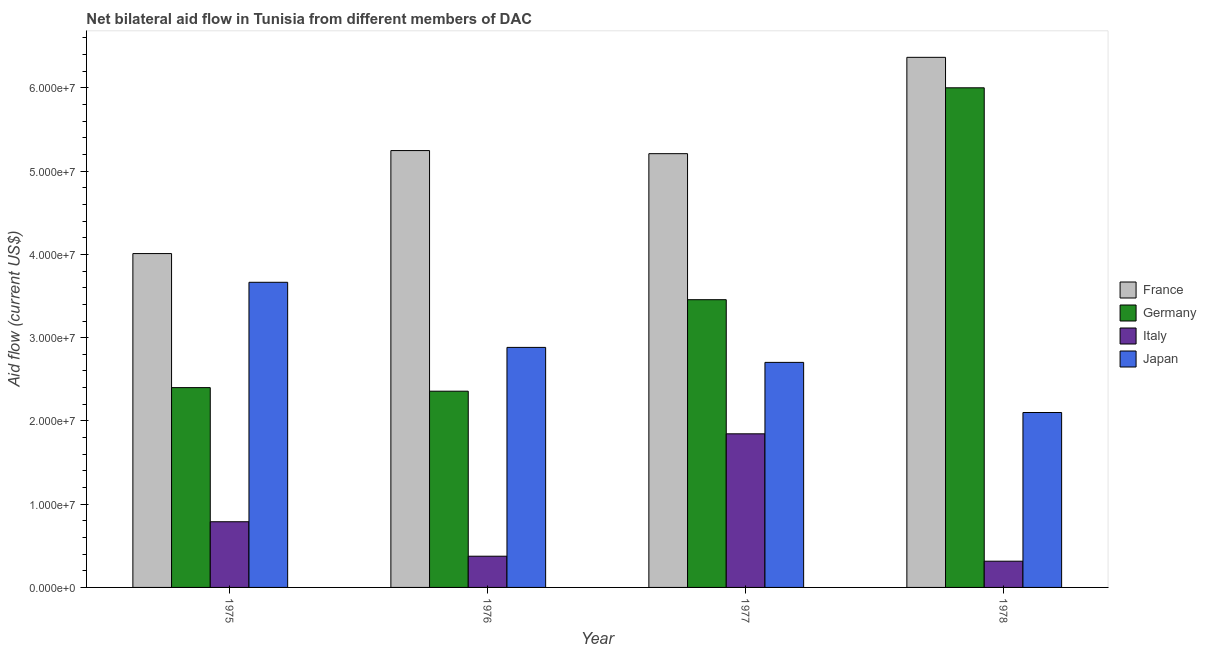Are the number of bars per tick equal to the number of legend labels?
Ensure brevity in your answer.  Yes. What is the label of the 4th group of bars from the left?
Offer a terse response. 1978. In how many cases, is the number of bars for a given year not equal to the number of legend labels?
Offer a very short reply. 0. What is the amount of aid given by japan in 1977?
Provide a short and direct response. 2.70e+07. Across all years, what is the maximum amount of aid given by france?
Your answer should be very brief. 6.37e+07. Across all years, what is the minimum amount of aid given by germany?
Give a very brief answer. 2.36e+07. In which year was the amount of aid given by italy maximum?
Ensure brevity in your answer.  1977. In which year was the amount of aid given by japan minimum?
Offer a very short reply. 1978. What is the total amount of aid given by italy in the graph?
Provide a short and direct response. 3.32e+07. What is the difference between the amount of aid given by japan in 1975 and that in 1976?
Make the answer very short. 7.82e+06. What is the difference between the amount of aid given by japan in 1976 and the amount of aid given by france in 1977?
Give a very brief answer. 1.80e+06. What is the average amount of aid given by italy per year?
Give a very brief answer. 8.31e+06. In the year 1977, what is the difference between the amount of aid given by italy and amount of aid given by france?
Your response must be concise. 0. What is the ratio of the amount of aid given by japan in 1976 to that in 1978?
Keep it short and to the point. 1.37. Is the amount of aid given by italy in 1976 less than that in 1978?
Make the answer very short. No. What is the difference between the highest and the second highest amount of aid given by germany?
Make the answer very short. 2.54e+07. What is the difference between the highest and the lowest amount of aid given by france?
Give a very brief answer. 2.36e+07. Is the sum of the amount of aid given by italy in 1975 and 1976 greater than the maximum amount of aid given by france across all years?
Offer a very short reply. No. Is it the case that in every year, the sum of the amount of aid given by france and amount of aid given by japan is greater than the sum of amount of aid given by germany and amount of aid given by italy?
Keep it short and to the point. Yes. What does the 1st bar from the left in 1978 represents?
Provide a short and direct response. France. What does the 4th bar from the right in 1976 represents?
Your answer should be very brief. France. Is it the case that in every year, the sum of the amount of aid given by france and amount of aid given by germany is greater than the amount of aid given by italy?
Offer a terse response. Yes. Does the graph contain any zero values?
Provide a succinct answer. No. How many legend labels are there?
Ensure brevity in your answer.  4. How are the legend labels stacked?
Provide a short and direct response. Vertical. What is the title of the graph?
Give a very brief answer. Net bilateral aid flow in Tunisia from different members of DAC. Does "Minerals" appear as one of the legend labels in the graph?
Provide a succinct answer. No. What is the Aid flow (current US$) of France in 1975?
Your answer should be very brief. 4.01e+07. What is the Aid flow (current US$) of Germany in 1975?
Provide a succinct answer. 2.40e+07. What is the Aid flow (current US$) in Italy in 1975?
Give a very brief answer. 7.89e+06. What is the Aid flow (current US$) of Japan in 1975?
Your answer should be very brief. 3.66e+07. What is the Aid flow (current US$) of France in 1976?
Provide a short and direct response. 5.25e+07. What is the Aid flow (current US$) of Germany in 1976?
Keep it short and to the point. 2.36e+07. What is the Aid flow (current US$) of Italy in 1976?
Your answer should be compact. 3.75e+06. What is the Aid flow (current US$) of Japan in 1976?
Offer a terse response. 2.88e+07. What is the Aid flow (current US$) of France in 1977?
Ensure brevity in your answer.  5.21e+07. What is the Aid flow (current US$) in Germany in 1977?
Ensure brevity in your answer.  3.46e+07. What is the Aid flow (current US$) in Italy in 1977?
Make the answer very short. 1.84e+07. What is the Aid flow (current US$) in Japan in 1977?
Offer a terse response. 2.70e+07. What is the Aid flow (current US$) in France in 1978?
Provide a succinct answer. 6.37e+07. What is the Aid flow (current US$) of Germany in 1978?
Offer a terse response. 6.00e+07. What is the Aid flow (current US$) in Italy in 1978?
Ensure brevity in your answer.  3.15e+06. What is the Aid flow (current US$) in Japan in 1978?
Provide a succinct answer. 2.10e+07. Across all years, what is the maximum Aid flow (current US$) in France?
Keep it short and to the point. 6.37e+07. Across all years, what is the maximum Aid flow (current US$) of Germany?
Your answer should be compact. 6.00e+07. Across all years, what is the maximum Aid flow (current US$) of Italy?
Give a very brief answer. 1.84e+07. Across all years, what is the maximum Aid flow (current US$) of Japan?
Give a very brief answer. 3.66e+07. Across all years, what is the minimum Aid flow (current US$) of France?
Ensure brevity in your answer.  4.01e+07. Across all years, what is the minimum Aid flow (current US$) of Germany?
Provide a short and direct response. 2.36e+07. Across all years, what is the minimum Aid flow (current US$) of Italy?
Your answer should be compact. 3.15e+06. Across all years, what is the minimum Aid flow (current US$) of Japan?
Your answer should be compact. 2.10e+07. What is the total Aid flow (current US$) in France in the graph?
Your response must be concise. 2.08e+08. What is the total Aid flow (current US$) in Germany in the graph?
Offer a very short reply. 1.42e+08. What is the total Aid flow (current US$) of Italy in the graph?
Your answer should be compact. 3.32e+07. What is the total Aid flow (current US$) of Japan in the graph?
Your response must be concise. 1.14e+08. What is the difference between the Aid flow (current US$) in France in 1975 and that in 1976?
Your response must be concise. -1.24e+07. What is the difference between the Aid flow (current US$) in Italy in 1975 and that in 1976?
Give a very brief answer. 4.14e+06. What is the difference between the Aid flow (current US$) in Japan in 1975 and that in 1976?
Give a very brief answer. 7.82e+06. What is the difference between the Aid flow (current US$) of France in 1975 and that in 1977?
Keep it short and to the point. -1.20e+07. What is the difference between the Aid flow (current US$) in Germany in 1975 and that in 1977?
Offer a very short reply. -1.06e+07. What is the difference between the Aid flow (current US$) of Italy in 1975 and that in 1977?
Your response must be concise. -1.06e+07. What is the difference between the Aid flow (current US$) in Japan in 1975 and that in 1977?
Your answer should be very brief. 9.62e+06. What is the difference between the Aid flow (current US$) of France in 1975 and that in 1978?
Your answer should be compact. -2.36e+07. What is the difference between the Aid flow (current US$) of Germany in 1975 and that in 1978?
Your response must be concise. -3.60e+07. What is the difference between the Aid flow (current US$) of Italy in 1975 and that in 1978?
Offer a very short reply. 4.74e+06. What is the difference between the Aid flow (current US$) of Japan in 1975 and that in 1978?
Provide a succinct answer. 1.56e+07. What is the difference between the Aid flow (current US$) in Germany in 1976 and that in 1977?
Your answer should be compact. -1.10e+07. What is the difference between the Aid flow (current US$) in Italy in 1976 and that in 1977?
Your answer should be very brief. -1.47e+07. What is the difference between the Aid flow (current US$) in Japan in 1976 and that in 1977?
Offer a terse response. 1.80e+06. What is the difference between the Aid flow (current US$) in France in 1976 and that in 1978?
Provide a succinct answer. -1.12e+07. What is the difference between the Aid flow (current US$) of Germany in 1976 and that in 1978?
Offer a very short reply. -3.64e+07. What is the difference between the Aid flow (current US$) in Italy in 1976 and that in 1978?
Offer a very short reply. 6.00e+05. What is the difference between the Aid flow (current US$) of Japan in 1976 and that in 1978?
Provide a succinct answer. 7.82e+06. What is the difference between the Aid flow (current US$) of France in 1977 and that in 1978?
Make the answer very short. -1.16e+07. What is the difference between the Aid flow (current US$) in Germany in 1977 and that in 1978?
Your answer should be very brief. -2.54e+07. What is the difference between the Aid flow (current US$) in Italy in 1977 and that in 1978?
Your answer should be very brief. 1.53e+07. What is the difference between the Aid flow (current US$) in Japan in 1977 and that in 1978?
Your answer should be very brief. 6.02e+06. What is the difference between the Aid flow (current US$) of France in 1975 and the Aid flow (current US$) of Germany in 1976?
Give a very brief answer. 1.65e+07. What is the difference between the Aid flow (current US$) of France in 1975 and the Aid flow (current US$) of Italy in 1976?
Keep it short and to the point. 3.64e+07. What is the difference between the Aid flow (current US$) of France in 1975 and the Aid flow (current US$) of Japan in 1976?
Give a very brief answer. 1.13e+07. What is the difference between the Aid flow (current US$) in Germany in 1975 and the Aid flow (current US$) in Italy in 1976?
Your answer should be compact. 2.02e+07. What is the difference between the Aid flow (current US$) of Germany in 1975 and the Aid flow (current US$) of Japan in 1976?
Ensure brevity in your answer.  -4.83e+06. What is the difference between the Aid flow (current US$) in Italy in 1975 and the Aid flow (current US$) in Japan in 1976?
Offer a terse response. -2.09e+07. What is the difference between the Aid flow (current US$) of France in 1975 and the Aid flow (current US$) of Germany in 1977?
Offer a terse response. 5.54e+06. What is the difference between the Aid flow (current US$) in France in 1975 and the Aid flow (current US$) in Italy in 1977?
Ensure brevity in your answer.  2.16e+07. What is the difference between the Aid flow (current US$) of France in 1975 and the Aid flow (current US$) of Japan in 1977?
Make the answer very short. 1.31e+07. What is the difference between the Aid flow (current US$) in Germany in 1975 and the Aid flow (current US$) in Italy in 1977?
Your response must be concise. 5.55e+06. What is the difference between the Aid flow (current US$) in Germany in 1975 and the Aid flow (current US$) in Japan in 1977?
Make the answer very short. -3.03e+06. What is the difference between the Aid flow (current US$) of Italy in 1975 and the Aid flow (current US$) of Japan in 1977?
Your answer should be compact. -1.91e+07. What is the difference between the Aid flow (current US$) of France in 1975 and the Aid flow (current US$) of Germany in 1978?
Provide a succinct answer. -1.99e+07. What is the difference between the Aid flow (current US$) in France in 1975 and the Aid flow (current US$) in Italy in 1978?
Your answer should be compact. 3.70e+07. What is the difference between the Aid flow (current US$) of France in 1975 and the Aid flow (current US$) of Japan in 1978?
Keep it short and to the point. 1.91e+07. What is the difference between the Aid flow (current US$) in Germany in 1975 and the Aid flow (current US$) in Italy in 1978?
Your answer should be very brief. 2.08e+07. What is the difference between the Aid flow (current US$) of Germany in 1975 and the Aid flow (current US$) of Japan in 1978?
Offer a terse response. 2.99e+06. What is the difference between the Aid flow (current US$) of Italy in 1975 and the Aid flow (current US$) of Japan in 1978?
Give a very brief answer. -1.31e+07. What is the difference between the Aid flow (current US$) of France in 1976 and the Aid flow (current US$) of Germany in 1977?
Provide a succinct answer. 1.79e+07. What is the difference between the Aid flow (current US$) in France in 1976 and the Aid flow (current US$) in Italy in 1977?
Give a very brief answer. 3.40e+07. What is the difference between the Aid flow (current US$) in France in 1976 and the Aid flow (current US$) in Japan in 1977?
Your response must be concise. 2.54e+07. What is the difference between the Aid flow (current US$) in Germany in 1976 and the Aid flow (current US$) in Italy in 1977?
Your answer should be compact. 5.12e+06. What is the difference between the Aid flow (current US$) of Germany in 1976 and the Aid flow (current US$) of Japan in 1977?
Ensure brevity in your answer.  -3.46e+06. What is the difference between the Aid flow (current US$) in Italy in 1976 and the Aid flow (current US$) in Japan in 1977?
Offer a terse response. -2.33e+07. What is the difference between the Aid flow (current US$) of France in 1976 and the Aid flow (current US$) of Germany in 1978?
Your answer should be very brief. -7.54e+06. What is the difference between the Aid flow (current US$) of France in 1976 and the Aid flow (current US$) of Italy in 1978?
Your answer should be very brief. 4.93e+07. What is the difference between the Aid flow (current US$) in France in 1976 and the Aid flow (current US$) in Japan in 1978?
Provide a succinct answer. 3.15e+07. What is the difference between the Aid flow (current US$) of Germany in 1976 and the Aid flow (current US$) of Italy in 1978?
Keep it short and to the point. 2.04e+07. What is the difference between the Aid flow (current US$) in Germany in 1976 and the Aid flow (current US$) in Japan in 1978?
Your answer should be compact. 2.56e+06. What is the difference between the Aid flow (current US$) in Italy in 1976 and the Aid flow (current US$) in Japan in 1978?
Offer a very short reply. -1.73e+07. What is the difference between the Aid flow (current US$) of France in 1977 and the Aid flow (current US$) of Germany in 1978?
Give a very brief answer. -7.91e+06. What is the difference between the Aid flow (current US$) of France in 1977 and the Aid flow (current US$) of Italy in 1978?
Your response must be concise. 4.90e+07. What is the difference between the Aid flow (current US$) of France in 1977 and the Aid flow (current US$) of Japan in 1978?
Make the answer very short. 3.11e+07. What is the difference between the Aid flow (current US$) in Germany in 1977 and the Aid flow (current US$) in Italy in 1978?
Keep it short and to the point. 3.14e+07. What is the difference between the Aid flow (current US$) in Germany in 1977 and the Aid flow (current US$) in Japan in 1978?
Make the answer very short. 1.36e+07. What is the difference between the Aid flow (current US$) in Italy in 1977 and the Aid flow (current US$) in Japan in 1978?
Provide a short and direct response. -2.56e+06. What is the average Aid flow (current US$) of France per year?
Your answer should be compact. 5.21e+07. What is the average Aid flow (current US$) in Germany per year?
Give a very brief answer. 3.55e+07. What is the average Aid flow (current US$) of Italy per year?
Make the answer very short. 8.31e+06. What is the average Aid flow (current US$) in Japan per year?
Make the answer very short. 2.84e+07. In the year 1975, what is the difference between the Aid flow (current US$) in France and Aid flow (current US$) in Germany?
Provide a short and direct response. 1.61e+07. In the year 1975, what is the difference between the Aid flow (current US$) of France and Aid flow (current US$) of Italy?
Your response must be concise. 3.22e+07. In the year 1975, what is the difference between the Aid flow (current US$) in France and Aid flow (current US$) in Japan?
Keep it short and to the point. 3.45e+06. In the year 1975, what is the difference between the Aid flow (current US$) of Germany and Aid flow (current US$) of Italy?
Your answer should be compact. 1.61e+07. In the year 1975, what is the difference between the Aid flow (current US$) in Germany and Aid flow (current US$) in Japan?
Make the answer very short. -1.26e+07. In the year 1975, what is the difference between the Aid flow (current US$) of Italy and Aid flow (current US$) of Japan?
Your response must be concise. -2.88e+07. In the year 1976, what is the difference between the Aid flow (current US$) in France and Aid flow (current US$) in Germany?
Offer a terse response. 2.89e+07. In the year 1976, what is the difference between the Aid flow (current US$) in France and Aid flow (current US$) in Italy?
Give a very brief answer. 4.87e+07. In the year 1976, what is the difference between the Aid flow (current US$) in France and Aid flow (current US$) in Japan?
Your answer should be compact. 2.36e+07. In the year 1976, what is the difference between the Aid flow (current US$) of Germany and Aid flow (current US$) of Italy?
Your answer should be compact. 1.98e+07. In the year 1976, what is the difference between the Aid flow (current US$) of Germany and Aid flow (current US$) of Japan?
Your answer should be compact. -5.26e+06. In the year 1976, what is the difference between the Aid flow (current US$) of Italy and Aid flow (current US$) of Japan?
Make the answer very short. -2.51e+07. In the year 1977, what is the difference between the Aid flow (current US$) of France and Aid flow (current US$) of Germany?
Your response must be concise. 1.75e+07. In the year 1977, what is the difference between the Aid flow (current US$) of France and Aid flow (current US$) of Italy?
Your answer should be compact. 3.36e+07. In the year 1977, what is the difference between the Aid flow (current US$) of France and Aid flow (current US$) of Japan?
Ensure brevity in your answer.  2.51e+07. In the year 1977, what is the difference between the Aid flow (current US$) of Germany and Aid flow (current US$) of Italy?
Your answer should be compact. 1.61e+07. In the year 1977, what is the difference between the Aid flow (current US$) in Germany and Aid flow (current US$) in Japan?
Make the answer very short. 7.53e+06. In the year 1977, what is the difference between the Aid flow (current US$) of Italy and Aid flow (current US$) of Japan?
Your response must be concise. -8.58e+06. In the year 1978, what is the difference between the Aid flow (current US$) in France and Aid flow (current US$) in Germany?
Make the answer very short. 3.66e+06. In the year 1978, what is the difference between the Aid flow (current US$) in France and Aid flow (current US$) in Italy?
Offer a very short reply. 6.05e+07. In the year 1978, what is the difference between the Aid flow (current US$) of France and Aid flow (current US$) of Japan?
Keep it short and to the point. 4.27e+07. In the year 1978, what is the difference between the Aid flow (current US$) of Germany and Aid flow (current US$) of Italy?
Keep it short and to the point. 5.69e+07. In the year 1978, what is the difference between the Aid flow (current US$) in Germany and Aid flow (current US$) in Japan?
Give a very brief answer. 3.90e+07. In the year 1978, what is the difference between the Aid flow (current US$) in Italy and Aid flow (current US$) in Japan?
Give a very brief answer. -1.79e+07. What is the ratio of the Aid flow (current US$) of France in 1975 to that in 1976?
Your answer should be very brief. 0.76. What is the ratio of the Aid flow (current US$) of Germany in 1975 to that in 1976?
Your response must be concise. 1.02. What is the ratio of the Aid flow (current US$) in Italy in 1975 to that in 1976?
Provide a short and direct response. 2.1. What is the ratio of the Aid flow (current US$) in Japan in 1975 to that in 1976?
Make the answer very short. 1.27. What is the ratio of the Aid flow (current US$) in France in 1975 to that in 1977?
Provide a short and direct response. 0.77. What is the ratio of the Aid flow (current US$) in Germany in 1975 to that in 1977?
Make the answer very short. 0.69. What is the ratio of the Aid flow (current US$) of Italy in 1975 to that in 1977?
Your answer should be compact. 0.43. What is the ratio of the Aid flow (current US$) of Japan in 1975 to that in 1977?
Give a very brief answer. 1.36. What is the ratio of the Aid flow (current US$) of France in 1975 to that in 1978?
Provide a short and direct response. 0.63. What is the ratio of the Aid flow (current US$) of Germany in 1975 to that in 1978?
Keep it short and to the point. 0.4. What is the ratio of the Aid flow (current US$) in Italy in 1975 to that in 1978?
Offer a terse response. 2.5. What is the ratio of the Aid flow (current US$) in Japan in 1975 to that in 1978?
Keep it short and to the point. 1.74. What is the ratio of the Aid flow (current US$) of France in 1976 to that in 1977?
Your answer should be compact. 1.01. What is the ratio of the Aid flow (current US$) of Germany in 1976 to that in 1977?
Your answer should be very brief. 0.68. What is the ratio of the Aid flow (current US$) of Italy in 1976 to that in 1977?
Ensure brevity in your answer.  0.2. What is the ratio of the Aid flow (current US$) in Japan in 1976 to that in 1977?
Offer a very short reply. 1.07. What is the ratio of the Aid flow (current US$) in France in 1976 to that in 1978?
Offer a very short reply. 0.82. What is the ratio of the Aid flow (current US$) in Germany in 1976 to that in 1978?
Give a very brief answer. 0.39. What is the ratio of the Aid flow (current US$) of Italy in 1976 to that in 1978?
Keep it short and to the point. 1.19. What is the ratio of the Aid flow (current US$) of Japan in 1976 to that in 1978?
Keep it short and to the point. 1.37. What is the ratio of the Aid flow (current US$) in France in 1977 to that in 1978?
Ensure brevity in your answer.  0.82. What is the ratio of the Aid flow (current US$) of Germany in 1977 to that in 1978?
Ensure brevity in your answer.  0.58. What is the ratio of the Aid flow (current US$) of Italy in 1977 to that in 1978?
Offer a terse response. 5.86. What is the ratio of the Aid flow (current US$) in Japan in 1977 to that in 1978?
Give a very brief answer. 1.29. What is the difference between the highest and the second highest Aid flow (current US$) of France?
Ensure brevity in your answer.  1.12e+07. What is the difference between the highest and the second highest Aid flow (current US$) in Germany?
Your answer should be compact. 2.54e+07. What is the difference between the highest and the second highest Aid flow (current US$) in Italy?
Offer a very short reply. 1.06e+07. What is the difference between the highest and the second highest Aid flow (current US$) of Japan?
Offer a very short reply. 7.82e+06. What is the difference between the highest and the lowest Aid flow (current US$) of France?
Your answer should be very brief. 2.36e+07. What is the difference between the highest and the lowest Aid flow (current US$) in Germany?
Offer a terse response. 3.64e+07. What is the difference between the highest and the lowest Aid flow (current US$) in Italy?
Provide a short and direct response. 1.53e+07. What is the difference between the highest and the lowest Aid flow (current US$) of Japan?
Provide a succinct answer. 1.56e+07. 